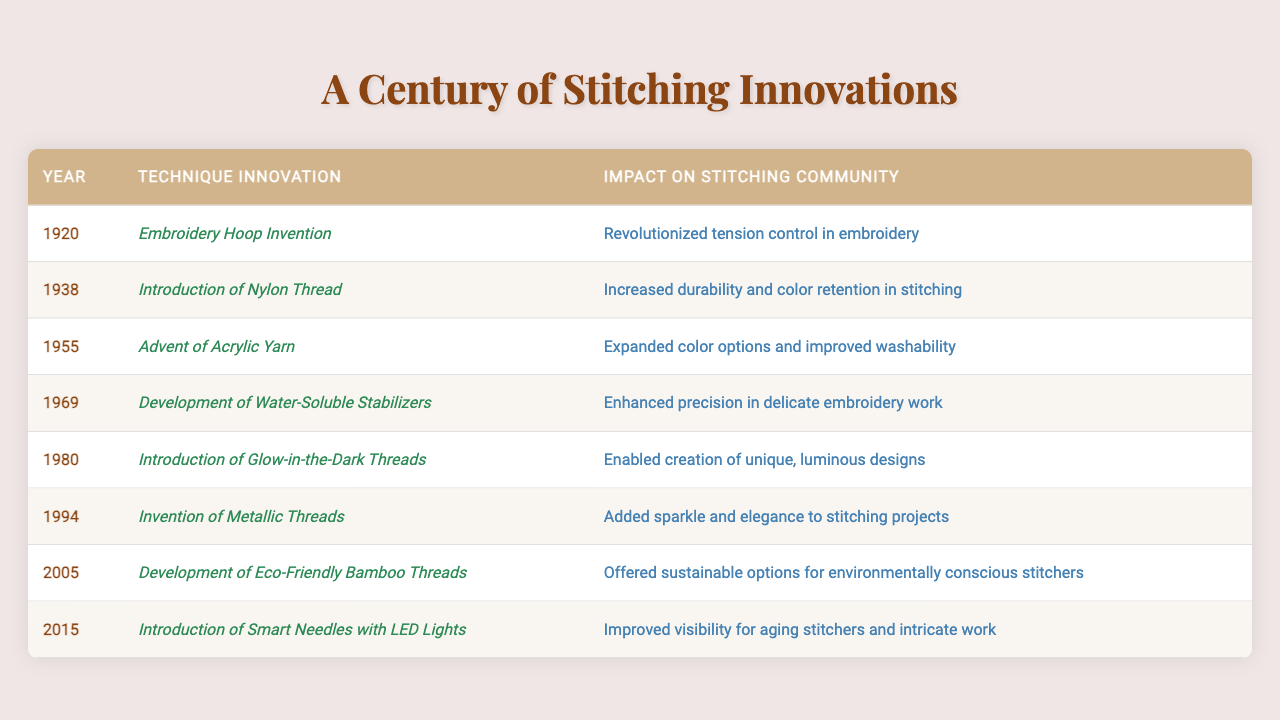What year was the Embroidery Hoop invented? The table lists the Embroidery Hoop Invention under the "Technique Innovation" column with the year 1920 in the "Year" column.
Answer: 1920 What impact did the Introduction of Nylon Thread in 1938 have on the stitching community? The table states that the Introduction of Nylon Thread increased durability and color retention in stitching.
Answer: Increased durability and color retention Which technique innovation introduced in 2005 offered sustainable options for stitchers? In the table, the Development of Eco-Friendly Bamboo Threads is listed as the technique innovation in 2005 and mentions its sustainable options for stitchers.
Answer: Eco-Friendly Bamboo Threads What was the impact of the Advent of Acrylic Yarn introduced in 1955? The row for 1955 mentions that the Advent of Acrylic Yarn expanded color options and improved washability in the stitching community.
Answer: Expanded color options and improved washability Which technique innovation added sparkle to stitching projects? The table indicates that the Invention of Metallic Threads in 1994 added sparkle and elegance to stitching projects.
Answer: Metallic Threads In what year did the introduction of Glow-in-the-Dark Threads occur, and what was its impact? The table shows that the Introduction of Glow-in-the-Dark Threads occurred in 1980 and enabled the creation of unique, luminous designs.
Answer: 1980; enabled unique, luminous designs Was the Development of Water-Soluble Stabilizers associated with enhanced precision for delicate works? The table confirms that the Development of Water-Soluble Stabilizers in 1969 enhanced precision in delicate embroidery work, confirming the statement as true.
Answer: Yes Count how many innovations improved visibility for stitchers, and identify them. The table mentions the Introduction of Smart Needles with LED Lights in 2015 as improving visibility. This is the only innovation that directly relates to improved visibility for stitchers.
Answer: 1; Smart Needles with LED Lights Which two innovations focused on enhancing design and creativity in stitching projects? The table shows that the Invention of Metallic Threads in 1994 and the Introduction of Glow-in-the-Dark Threads in 1980 both aimed to enhance design and creativity in stitching.
Answer: Metallic Threads, Glow-in-the-Dark Threads What was the most recent innovation listed in the table and what year did it occur? According to the table, the most recent innovation is the Introduction of Smart Needles with LED Lights, which occurred in 2015.
Answer: Smart Needles with LED Lights in 2015 